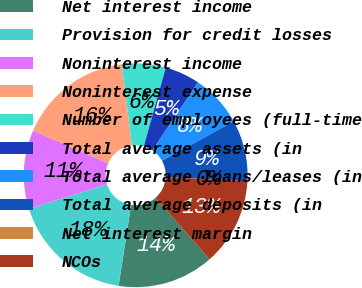<chart> <loc_0><loc_0><loc_500><loc_500><pie_chart><fcel>Net interest income<fcel>Provision for credit losses<fcel>Noninterest income<fcel>Noninterest expense<fcel>Number of employees (full-time<fcel>Total average assets (in<fcel>Total average loans/leases (in<fcel>Total average deposits (in<fcel>Net interest margin<fcel>NCOs<nl><fcel>13.92%<fcel>17.72%<fcel>11.39%<fcel>16.46%<fcel>6.33%<fcel>5.06%<fcel>7.59%<fcel>8.86%<fcel>0.0%<fcel>12.66%<nl></chart> 